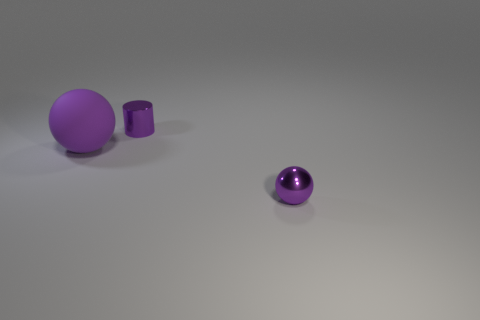Are there any other small cylinders of the same color as the small shiny cylinder? After examining the image, there are no other small cylinders that match the color of the small shiny purple cylinder displayed. 